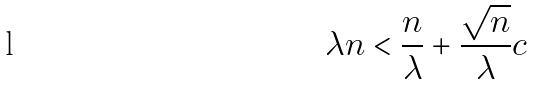Convert formula to latex. <formula><loc_0><loc_0><loc_500><loc_500>\lambda n < \frac { n } { \lambda } + \frac { \sqrt { n } } { \lambda } c</formula> 